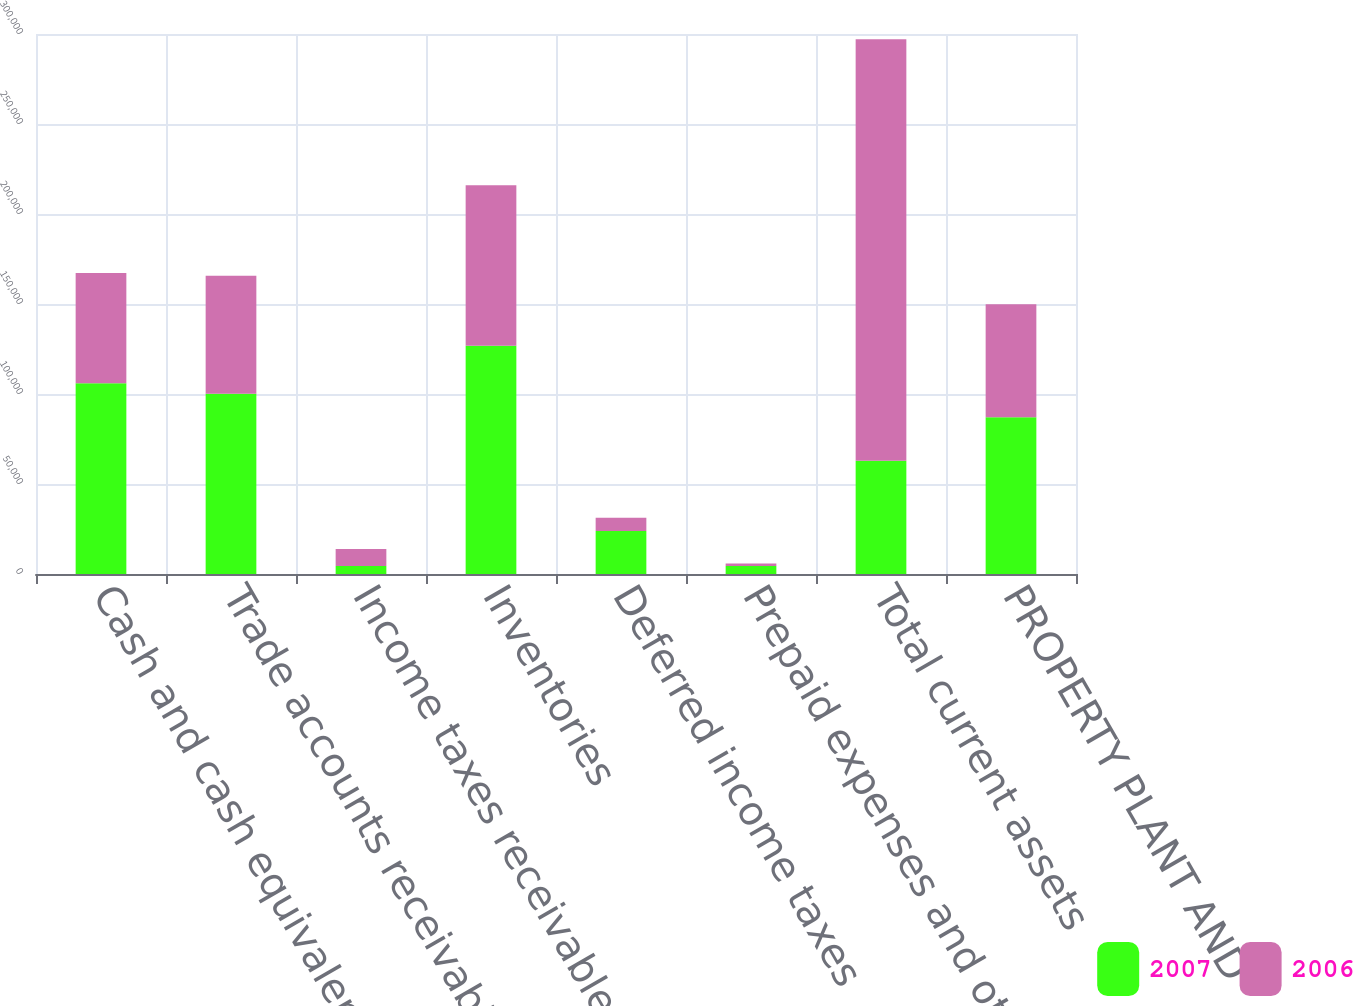Convert chart to OTSL. <chart><loc_0><loc_0><loc_500><loc_500><stacked_bar_chart><ecel><fcel>Cash and cash equivalents<fcel>Trade accounts receivable-Net<fcel>Income taxes receivable<fcel>Inventories<fcel>Deferred income taxes<fcel>Prepaid expenses and other<fcel>Total current assets<fcel>PROPERTY PLANT AND<nl><fcel>2007<fcel>105946<fcel>100094<fcel>4472<fcel>126763<fcel>23923<fcel>4401<fcel>62851<fcel>87074<nl><fcel>2006<fcel>61217<fcel>65568<fcel>9366<fcel>89243<fcel>7390<fcel>1397<fcel>234181<fcel>62851<nl></chart> 